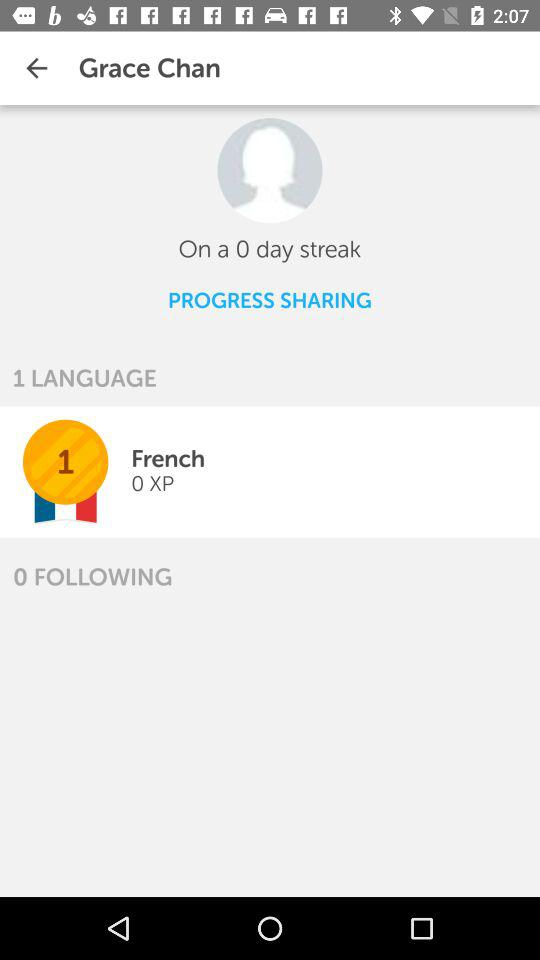What is the user name? The user name is Grace Chan. 